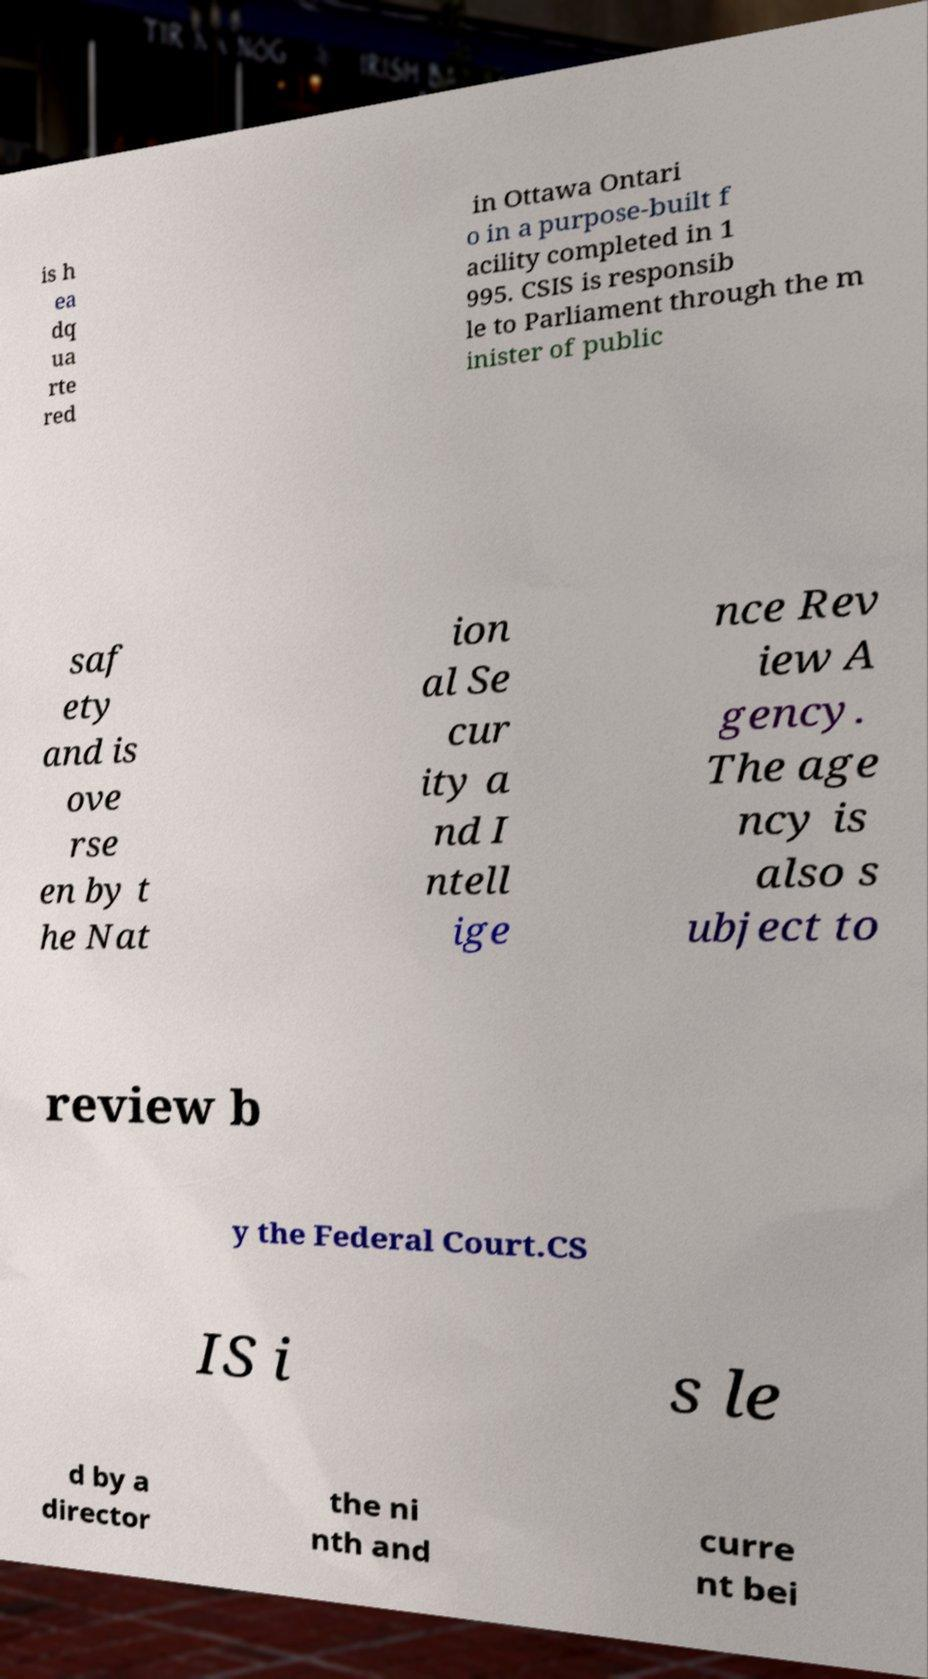Please identify and transcribe the text found in this image. is h ea dq ua rte red in Ottawa Ontari o in a purpose-built f acility completed in 1 995. CSIS is responsib le to Parliament through the m inister of public saf ety and is ove rse en by t he Nat ion al Se cur ity a nd I ntell ige nce Rev iew A gency. The age ncy is also s ubject to review b y the Federal Court.CS IS i s le d by a director the ni nth and curre nt bei 